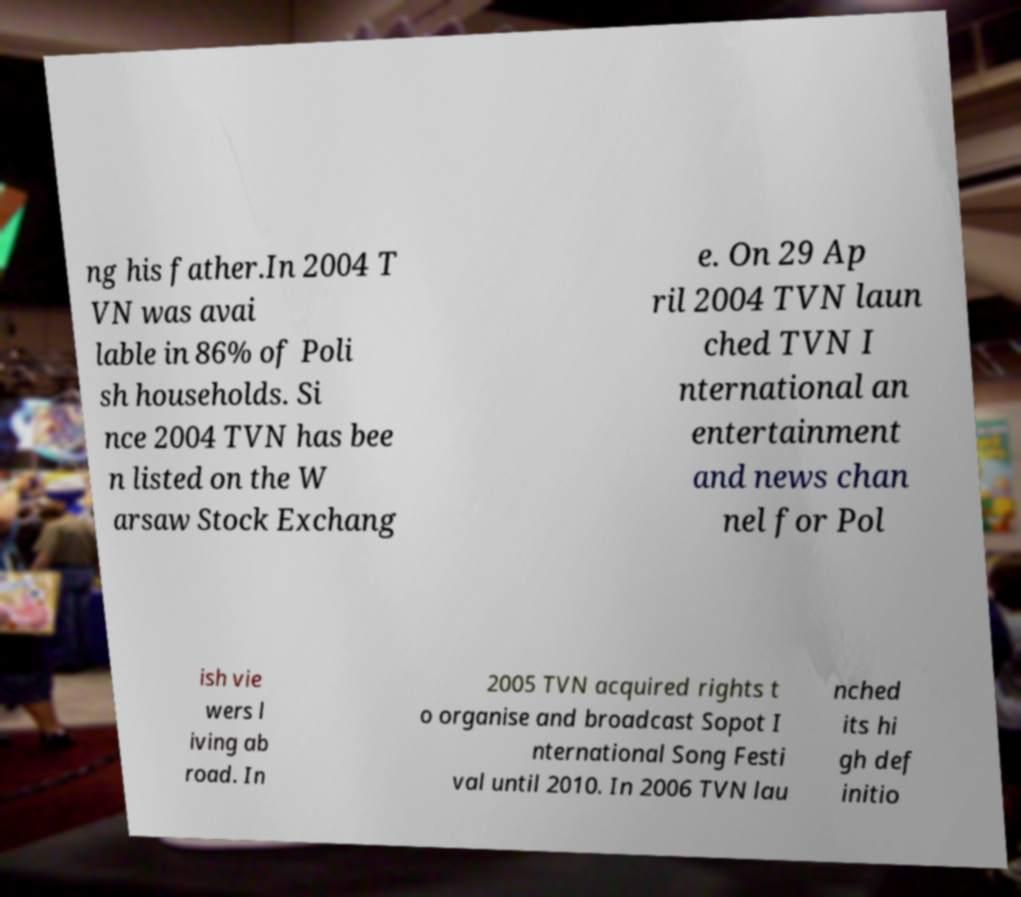For documentation purposes, I need the text within this image transcribed. Could you provide that? ng his father.In 2004 T VN was avai lable in 86% of Poli sh households. Si nce 2004 TVN has bee n listed on the W arsaw Stock Exchang e. On 29 Ap ril 2004 TVN laun ched TVN I nternational an entertainment and news chan nel for Pol ish vie wers l iving ab road. In 2005 TVN acquired rights t o organise and broadcast Sopot I nternational Song Festi val until 2010. In 2006 TVN lau nched its hi gh def initio 